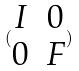Convert formula to latex. <formula><loc_0><loc_0><loc_500><loc_500>( \begin{matrix} I & 0 \\ 0 & F \end{matrix} )</formula> 